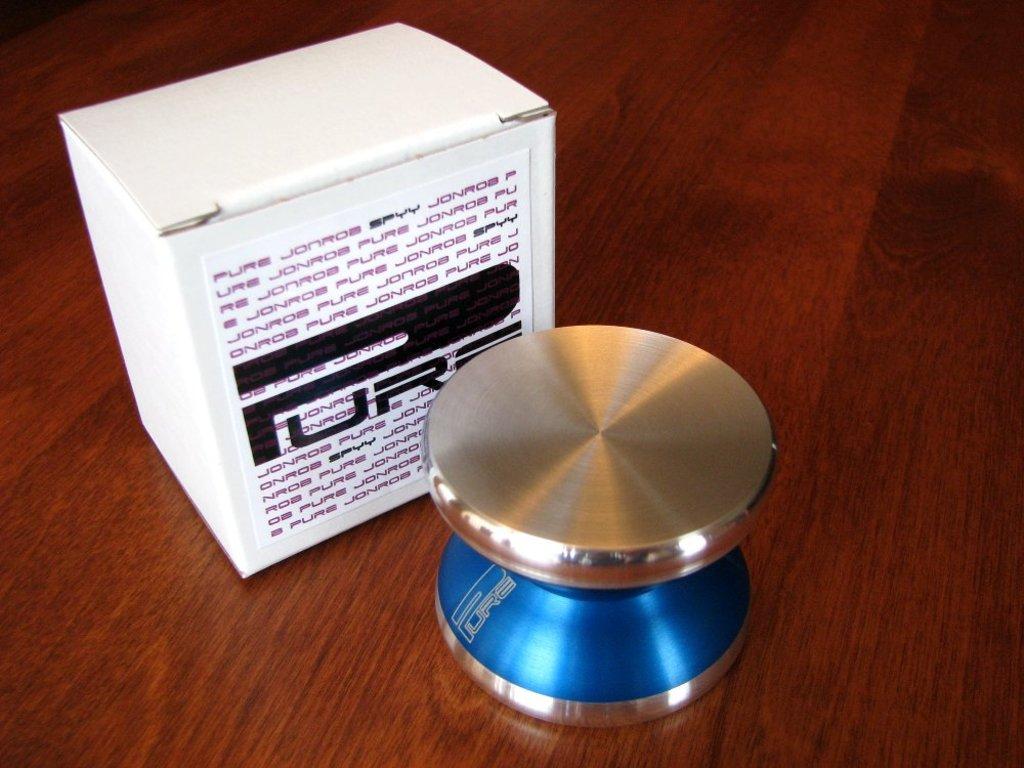What is the company name on the box?
Your answer should be compact. Pure. What does the small black font say?
Provide a short and direct response. Spyy. 